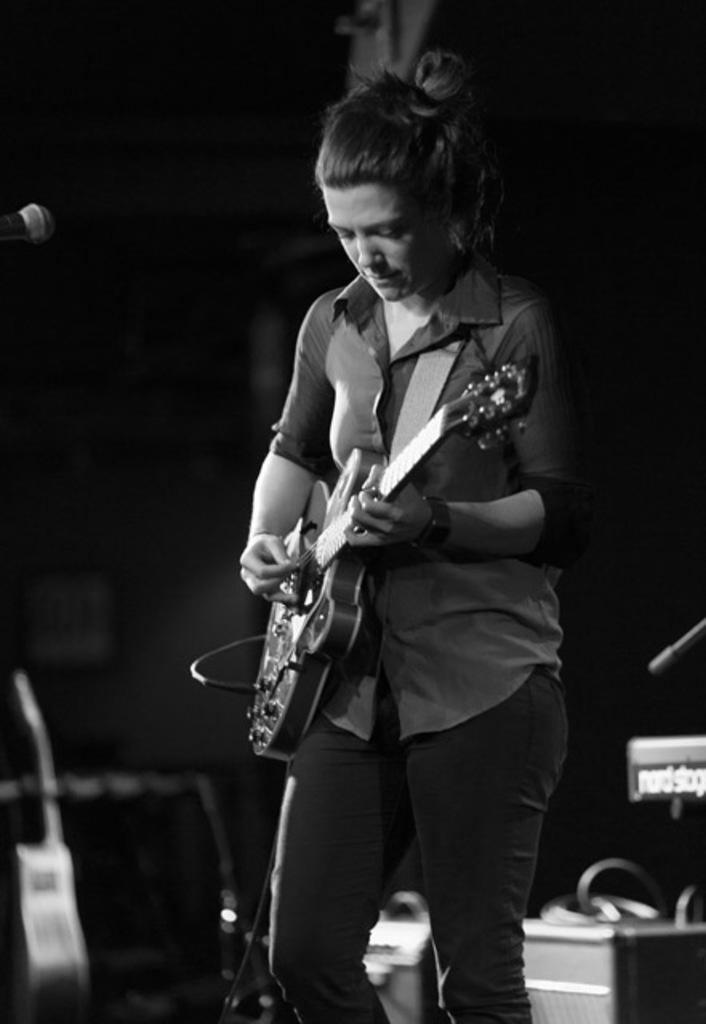What type of setting is depicted in the image? The image is of an indoor setting. Who is the main subject in the image? There is a woman in the center of the image. What is the woman doing in the image? The woman is standing and playing a guitar. What can be seen in the background of the image? There is a machine and a wall in the background of the image. Can you hear the woman singing while playing the guitar in the image? The image is a still image, so we cannot hear any sounds, including the woman singing. 